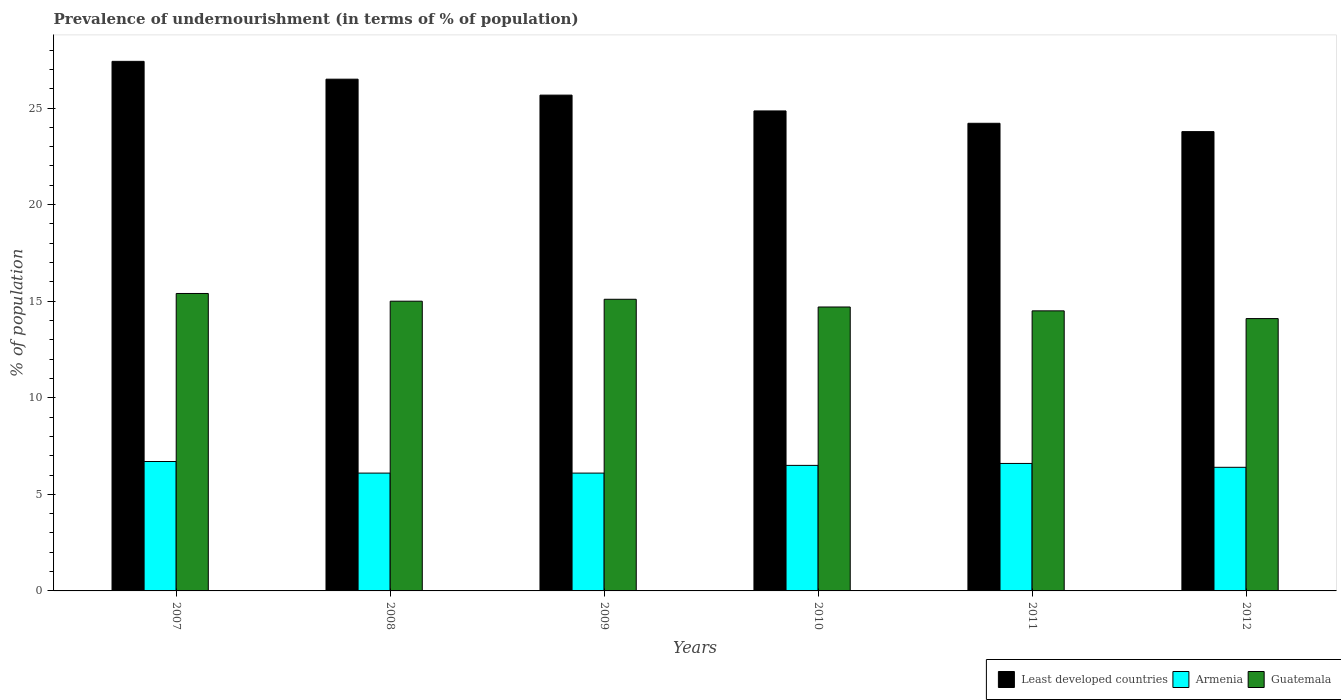How many groups of bars are there?
Offer a very short reply. 6. Are the number of bars per tick equal to the number of legend labels?
Offer a terse response. Yes. How many bars are there on the 6th tick from the left?
Your response must be concise. 3. What is the label of the 5th group of bars from the left?
Provide a succinct answer. 2011. In how many cases, is the number of bars for a given year not equal to the number of legend labels?
Provide a short and direct response. 0. Across all years, what is the maximum percentage of undernourished population in Armenia?
Your response must be concise. 6.7. What is the total percentage of undernourished population in Guatemala in the graph?
Provide a short and direct response. 88.8. What is the difference between the percentage of undernourished population in Armenia in 2007 and that in 2011?
Give a very brief answer. 0.1. What is the difference between the percentage of undernourished population in Armenia in 2007 and the percentage of undernourished population in Guatemala in 2008?
Your answer should be compact. -8.3. What is the average percentage of undernourished population in Guatemala per year?
Offer a terse response. 14.8. In the year 2008, what is the difference between the percentage of undernourished population in Guatemala and percentage of undernourished population in Least developed countries?
Provide a short and direct response. -11.49. In how many years, is the percentage of undernourished population in Guatemala greater than 2 %?
Give a very brief answer. 6. What is the ratio of the percentage of undernourished population in Least developed countries in 2010 to that in 2012?
Your answer should be very brief. 1.05. Is the percentage of undernourished population in Armenia in 2008 less than that in 2010?
Ensure brevity in your answer.  Yes. What is the difference between the highest and the second highest percentage of undernourished population in Least developed countries?
Give a very brief answer. 0.92. What is the difference between the highest and the lowest percentage of undernourished population in Least developed countries?
Offer a very short reply. 3.64. In how many years, is the percentage of undernourished population in Least developed countries greater than the average percentage of undernourished population in Least developed countries taken over all years?
Keep it short and to the point. 3. What does the 1st bar from the left in 2007 represents?
Your answer should be very brief. Least developed countries. What does the 3rd bar from the right in 2011 represents?
Keep it short and to the point. Least developed countries. Is it the case that in every year, the sum of the percentage of undernourished population in Armenia and percentage of undernourished population in Guatemala is greater than the percentage of undernourished population in Least developed countries?
Give a very brief answer. No. Are all the bars in the graph horizontal?
Keep it short and to the point. No. How many years are there in the graph?
Offer a very short reply. 6. Are the values on the major ticks of Y-axis written in scientific E-notation?
Make the answer very short. No. Does the graph contain any zero values?
Your response must be concise. No. Does the graph contain grids?
Provide a short and direct response. No. What is the title of the graph?
Ensure brevity in your answer.  Prevalence of undernourishment (in terms of % of population). What is the label or title of the X-axis?
Keep it short and to the point. Years. What is the label or title of the Y-axis?
Provide a succinct answer. % of population. What is the % of population of Least developed countries in 2007?
Provide a short and direct response. 27.42. What is the % of population of Armenia in 2007?
Your answer should be very brief. 6.7. What is the % of population of Guatemala in 2007?
Offer a very short reply. 15.4. What is the % of population of Least developed countries in 2008?
Offer a very short reply. 26.49. What is the % of population in Least developed countries in 2009?
Offer a terse response. 25.67. What is the % of population of Guatemala in 2009?
Offer a terse response. 15.1. What is the % of population in Least developed countries in 2010?
Keep it short and to the point. 24.85. What is the % of population of Guatemala in 2010?
Provide a succinct answer. 14.7. What is the % of population in Least developed countries in 2011?
Provide a succinct answer. 24.21. What is the % of population in Least developed countries in 2012?
Your answer should be very brief. 23.78. What is the % of population in Armenia in 2012?
Your answer should be very brief. 6.4. What is the % of population of Guatemala in 2012?
Ensure brevity in your answer.  14.1. Across all years, what is the maximum % of population of Least developed countries?
Your response must be concise. 27.42. Across all years, what is the maximum % of population in Armenia?
Keep it short and to the point. 6.7. Across all years, what is the minimum % of population of Least developed countries?
Give a very brief answer. 23.78. Across all years, what is the minimum % of population in Armenia?
Give a very brief answer. 6.1. What is the total % of population in Least developed countries in the graph?
Your answer should be compact. 152.43. What is the total % of population in Armenia in the graph?
Provide a short and direct response. 38.4. What is the total % of population of Guatemala in the graph?
Provide a short and direct response. 88.8. What is the difference between the % of population in Least developed countries in 2007 and that in 2008?
Your answer should be compact. 0.92. What is the difference between the % of population in Guatemala in 2007 and that in 2008?
Provide a succinct answer. 0.4. What is the difference between the % of population of Least developed countries in 2007 and that in 2009?
Your answer should be compact. 1.75. What is the difference between the % of population of Guatemala in 2007 and that in 2009?
Your answer should be very brief. 0.3. What is the difference between the % of population of Least developed countries in 2007 and that in 2010?
Offer a very short reply. 2.57. What is the difference between the % of population of Armenia in 2007 and that in 2010?
Offer a terse response. 0.2. What is the difference between the % of population of Guatemala in 2007 and that in 2010?
Your response must be concise. 0.7. What is the difference between the % of population of Least developed countries in 2007 and that in 2011?
Give a very brief answer. 3.21. What is the difference between the % of population in Armenia in 2007 and that in 2011?
Your answer should be compact. 0.1. What is the difference between the % of population of Guatemala in 2007 and that in 2011?
Offer a very short reply. 0.9. What is the difference between the % of population of Least developed countries in 2007 and that in 2012?
Your answer should be very brief. 3.64. What is the difference between the % of population in Armenia in 2007 and that in 2012?
Provide a short and direct response. 0.3. What is the difference between the % of population in Guatemala in 2007 and that in 2012?
Your answer should be compact. 1.3. What is the difference between the % of population of Least developed countries in 2008 and that in 2009?
Ensure brevity in your answer.  0.82. What is the difference between the % of population of Armenia in 2008 and that in 2009?
Ensure brevity in your answer.  0. What is the difference between the % of population in Least developed countries in 2008 and that in 2010?
Your answer should be very brief. 1.64. What is the difference between the % of population in Armenia in 2008 and that in 2010?
Provide a succinct answer. -0.4. What is the difference between the % of population in Least developed countries in 2008 and that in 2011?
Offer a terse response. 2.28. What is the difference between the % of population in Armenia in 2008 and that in 2011?
Your answer should be compact. -0.5. What is the difference between the % of population of Guatemala in 2008 and that in 2011?
Give a very brief answer. 0.5. What is the difference between the % of population in Least developed countries in 2008 and that in 2012?
Provide a short and direct response. 2.71. What is the difference between the % of population in Least developed countries in 2009 and that in 2010?
Offer a very short reply. 0.82. What is the difference between the % of population in Armenia in 2009 and that in 2010?
Provide a succinct answer. -0.4. What is the difference between the % of population of Least developed countries in 2009 and that in 2011?
Your answer should be compact. 1.46. What is the difference between the % of population in Least developed countries in 2009 and that in 2012?
Provide a succinct answer. 1.89. What is the difference between the % of population in Armenia in 2009 and that in 2012?
Provide a succinct answer. -0.3. What is the difference between the % of population of Least developed countries in 2010 and that in 2011?
Provide a short and direct response. 0.64. What is the difference between the % of population of Armenia in 2010 and that in 2011?
Your response must be concise. -0.1. What is the difference between the % of population of Guatemala in 2010 and that in 2011?
Offer a very short reply. 0.2. What is the difference between the % of population of Least developed countries in 2010 and that in 2012?
Make the answer very short. 1.07. What is the difference between the % of population in Armenia in 2010 and that in 2012?
Provide a short and direct response. 0.1. What is the difference between the % of population of Guatemala in 2010 and that in 2012?
Keep it short and to the point. 0.6. What is the difference between the % of population of Least developed countries in 2011 and that in 2012?
Offer a terse response. 0.43. What is the difference between the % of population in Armenia in 2011 and that in 2012?
Your answer should be compact. 0.2. What is the difference between the % of population of Guatemala in 2011 and that in 2012?
Provide a succinct answer. 0.4. What is the difference between the % of population in Least developed countries in 2007 and the % of population in Armenia in 2008?
Your response must be concise. 21.32. What is the difference between the % of population in Least developed countries in 2007 and the % of population in Guatemala in 2008?
Provide a succinct answer. 12.42. What is the difference between the % of population of Armenia in 2007 and the % of population of Guatemala in 2008?
Keep it short and to the point. -8.3. What is the difference between the % of population in Least developed countries in 2007 and the % of population in Armenia in 2009?
Give a very brief answer. 21.32. What is the difference between the % of population in Least developed countries in 2007 and the % of population in Guatemala in 2009?
Your answer should be very brief. 12.32. What is the difference between the % of population in Least developed countries in 2007 and the % of population in Armenia in 2010?
Offer a very short reply. 20.92. What is the difference between the % of population of Least developed countries in 2007 and the % of population of Guatemala in 2010?
Provide a short and direct response. 12.72. What is the difference between the % of population in Least developed countries in 2007 and the % of population in Armenia in 2011?
Your answer should be compact. 20.82. What is the difference between the % of population of Least developed countries in 2007 and the % of population of Guatemala in 2011?
Your response must be concise. 12.92. What is the difference between the % of population in Least developed countries in 2007 and the % of population in Armenia in 2012?
Your answer should be very brief. 21.02. What is the difference between the % of population of Least developed countries in 2007 and the % of population of Guatemala in 2012?
Your answer should be compact. 13.32. What is the difference between the % of population in Least developed countries in 2008 and the % of population in Armenia in 2009?
Make the answer very short. 20.39. What is the difference between the % of population of Least developed countries in 2008 and the % of population of Guatemala in 2009?
Make the answer very short. 11.39. What is the difference between the % of population of Armenia in 2008 and the % of population of Guatemala in 2009?
Make the answer very short. -9. What is the difference between the % of population of Least developed countries in 2008 and the % of population of Armenia in 2010?
Your answer should be very brief. 19.99. What is the difference between the % of population in Least developed countries in 2008 and the % of population in Guatemala in 2010?
Your answer should be compact. 11.79. What is the difference between the % of population in Least developed countries in 2008 and the % of population in Armenia in 2011?
Your answer should be very brief. 19.89. What is the difference between the % of population in Least developed countries in 2008 and the % of population in Guatemala in 2011?
Keep it short and to the point. 11.99. What is the difference between the % of population in Least developed countries in 2008 and the % of population in Armenia in 2012?
Provide a short and direct response. 20.09. What is the difference between the % of population in Least developed countries in 2008 and the % of population in Guatemala in 2012?
Ensure brevity in your answer.  12.39. What is the difference between the % of population of Armenia in 2008 and the % of population of Guatemala in 2012?
Give a very brief answer. -8. What is the difference between the % of population in Least developed countries in 2009 and the % of population in Armenia in 2010?
Keep it short and to the point. 19.17. What is the difference between the % of population of Least developed countries in 2009 and the % of population of Guatemala in 2010?
Your answer should be very brief. 10.97. What is the difference between the % of population of Least developed countries in 2009 and the % of population of Armenia in 2011?
Provide a succinct answer. 19.07. What is the difference between the % of population of Least developed countries in 2009 and the % of population of Guatemala in 2011?
Ensure brevity in your answer.  11.17. What is the difference between the % of population of Least developed countries in 2009 and the % of population of Armenia in 2012?
Provide a short and direct response. 19.27. What is the difference between the % of population of Least developed countries in 2009 and the % of population of Guatemala in 2012?
Your answer should be compact. 11.57. What is the difference between the % of population in Least developed countries in 2010 and the % of population in Armenia in 2011?
Provide a succinct answer. 18.25. What is the difference between the % of population in Least developed countries in 2010 and the % of population in Guatemala in 2011?
Ensure brevity in your answer.  10.35. What is the difference between the % of population of Armenia in 2010 and the % of population of Guatemala in 2011?
Offer a terse response. -8. What is the difference between the % of population of Least developed countries in 2010 and the % of population of Armenia in 2012?
Ensure brevity in your answer.  18.45. What is the difference between the % of population in Least developed countries in 2010 and the % of population in Guatemala in 2012?
Provide a short and direct response. 10.75. What is the difference between the % of population in Armenia in 2010 and the % of population in Guatemala in 2012?
Your answer should be compact. -7.6. What is the difference between the % of population of Least developed countries in 2011 and the % of population of Armenia in 2012?
Ensure brevity in your answer.  17.81. What is the difference between the % of population of Least developed countries in 2011 and the % of population of Guatemala in 2012?
Offer a very short reply. 10.11. What is the average % of population of Least developed countries per year?
Give a very brief answer. 25.4. In the year 2007, what is the difference between the % of population in Least developed countries and % of population in Armenia?
Give a very brief answer. 20.72. In the year 2007, what is the difference between the % of population of Least developed countries and % of population of Guatemala?
Give a very brief answer. 12.02. In the year 2007, what is the difference between the % of population in Armenia and % of population in Guatemala?
Offer a very short reply. -8.7. In the year 2008, what is the difference between the % of population of Least developed countries and % of population of Armenia?
Offer a terse response. 20.39. In the year 2008, what is the difference between the % of population of Least developed countries and % of population of Guatemala?
Your answer should be very brief. 11.49. In the year 2008, what is the difference between the % of population of Armenia and % of population of Guatemala?
Provide a succinct answer. -8.9. In the year 2009, what is the difference between the % of population of Least developed countries and % of population of Armenia?
Your answer should be compact. 19.57. In the year 2009, what is the difference between the % of population of Least developed countries and % of population of Guatemala?
Your answer should be compact. 10.57. In the year 2010, what is the difference between the % of population in Least developed countries and % of population in Armenia?
Offer a very short reply. 18.35. In the year 2010, what is the difference between the % of population of Least developed countries and % of population of Guatemala?
Give a very brief answer. 10.15. In the year 2010, what is the difference between the % of population in Armenia and % of population in Guatemala?
Provide a short and direct response. -8.2. In the year 2011, what is the difference between the % of population of Least developed countries and % of population of Armenia?
Provide a short and direct response. 17.61. In the year 2011, what is the difference between the % of population in Least developed countries and % of population in Guatemala?
Ensure brevity in your answer.  9.71. In the year 2012, what is the difference between the % of population in Least developed countries and % of population in Armenia?
Ensure brevity in your answer.  17.38. In the year 2012, what is the difference between the % of population of Least developed countries and % of population of Guatemala?
Ensure brevity in your answer.  9.68. What is the ratio of the % of population in Least developed countries in 2007 to that in 2008?
Your response must be concise. 1.03. What is the ratio of the % of population in Armenia in 2007 to that in 2008?
Give a very brief answer. 1.1. What is the ratio of the % of population of Guatemala in 2007 to that in 2008?
Make the answer very short. 1.03. What is the ratio of the % of population in Least developed countries in 2007 to that in 2009?
Provide a short and direct response. 1.07. What is the ratio of the % of population in Armenia in 2007 to that in 2009?
Keep it short and to the point. 1.1. What is the ratio of the % of population of Guatemala in 2007 to that in 2009?
Provide a short and direct response. 1.02. What is the ratio of the % of population of Least developed countries in 2007 to that in 2010?
Provide a short and direct response. 1.1. What is the ratio of the % of population in Armenia in 2007 to that in 2010?
Your response must be concise. 1.03. What is the ratio of the % of population in Guatemala in 2007 to that in 2010?
Offer a very short reply. 1.05. What is the ratio of the % of population of Least developed countries in 2007 to that in 2011?
Provide a succinct answer. 1.13. What is the ratio of the % of population of Armenia in 2007 to that in 2011?
Keep it short and to the point. 1.02. What is the ratio of the % of population of Guatemala in 2007 to that in 2011?
Keep it short and to the point. 1.06. What is the ratio of the % of population in Least developed countries in 2007 to that in 2012?
Give a very brief answer. 1.15. What is the ratio of the % of population of Armenia in 2007 to that in 2012?
Your answer should be compact. 1.05. What is the ratio of the % of population in Guatemala in 2007 to that in 2012?
Ensure brevity in your answer.  1.09. What is the ratio of the % of population in Least developed countries in 2008 to that in 2009?
Provide a short and direct response. 1.03. What is the ratio of the % of population of Armenia in 2008 to that in 2009?
Ensure brevity in your answer.  1. What is the ratio of the % of population in Guatemala in 2008 to that in 2009?
Your answer should be compact. 0.99. What is the ratio of the % of population in Least developed countries in 2008 to that in 2010?
Give a very brief answer. 1.07. What is the ratio of the % of population of Armenia in 2008 to that in 2010?
Provide a short and direct response. 0.94. What is the ratio of the % of population in Guatemala in 2008 to that in 2010?
Your answer should be very brief. 1.02. What is the ratio of the % of population of Least developed countries in 2008 to that in 2011?
Keep it short and to the point. 1.09. What is the ratio of the % of population in Armenia in 2008 to that in 2011?
Make the answer very short. 0.92. What is the ratio of the % of population in Guatemala in 2008 to that in 2011?
Keep it short and to the point. 1.03. What is the ratio of the % of population of Least developed countries in 2008 to that in 2012?
Keep it short and to the point. 1.11. What is the ratio of the % of population in Armenia in 2008 to that in 2012?
Offer a very short reply. 0.95. What is the ratio of the % of population of Guatemala in 2008 to that in 2012?
Make the answer very short. 1.06. What is the ratio of the % of population of Least developed countries in 2009 to that in 2010?
Offer a very short reply. 1.03. What is the ratio of the % of population of Armenia in 2009 to that in 2010?
Your answer should be compact. 0.94. What is the ratio of the % of population of Guatemala in 2009 to that in 2010?
Offer a very short reply. 1.03. What is the ratio of the % of population of Least developed countries in 2009 to that in 2011?
Your answer should be very brief. 1.06. What is the ratio of the % of population of Armenia in 2009 to that in 2011?
Your answer should be compact. 0.92. What is the ratio of the % of population of Guatemala in 2009 to that in 2011?
Make the answer very short. 1.04. What is the ratio of the % of population in Least developed countries in 2009 to that in 2012?
Your response must be concise. 1.08. What is the ratio of the % of population in Armenia in 2009 to that in 2012?
Ensure brevity in your answer.  0.95. What is the ratio of the % of population in Guatemala in 2009 to that in 2012?
Offer a very short reply. 1.07. What is the ratio of the % of population of Least developed countries in 2010 to that in 2011?
Provide a short and direct response. 1.03. What is the ratio of the % of population in Armenia in 2010 to that in 2011?
Ensure brevity in your answer.  0.98. What is the ratio of the % of population in Guatemala in 2010 to that in 2011?
Make the answer very short. 1.01. What is the ratio of the % of population of Least developed countries in 2010 to that in 2012?
Ensure brevity in your answer.  1.04. What is the ratio of the % of population in Armenia in 2010 to that in 2012?
Give a very brief answer. 1.02. What is the ratio of the % of population in Guatemala in 2010 to that in 2012?
Provide a short and direct response. 1.04. What is the ratio of the % of population of Least developed countries in 2011 to that in 2012?
Your answer should be very brief. 1.02. What is the ratio of the % of population of Armenia in 2011 to that in 2012?
Provide a short and direct response. 1.03. What is the ratio of the % of population in Guatemala in 2011 to that in 2012?
Ensure brevity in your answer.  1.03. What is the difference between the highest and the second highest % of population of Least developed countries?
Give a very brief answer. 0.92. What is the difference between the highest and the second highest % of population in Armenia?
Offer a terse response. 0.1. What is the difference between the highest and the second highest % of population in Guatemala?
Offer a terse response. 0.3. What is the difference between the highest and the lowest % of population in Least developed countries?
Keep it short and to the point. 3.64. What is the difference between the highest and the lowest % of population in Armenia?
Offer a very short reply. 0.6. What is the difference between the highest and the lowest % of population of Guatemala?
Your answer should be very brief. 1.3. 